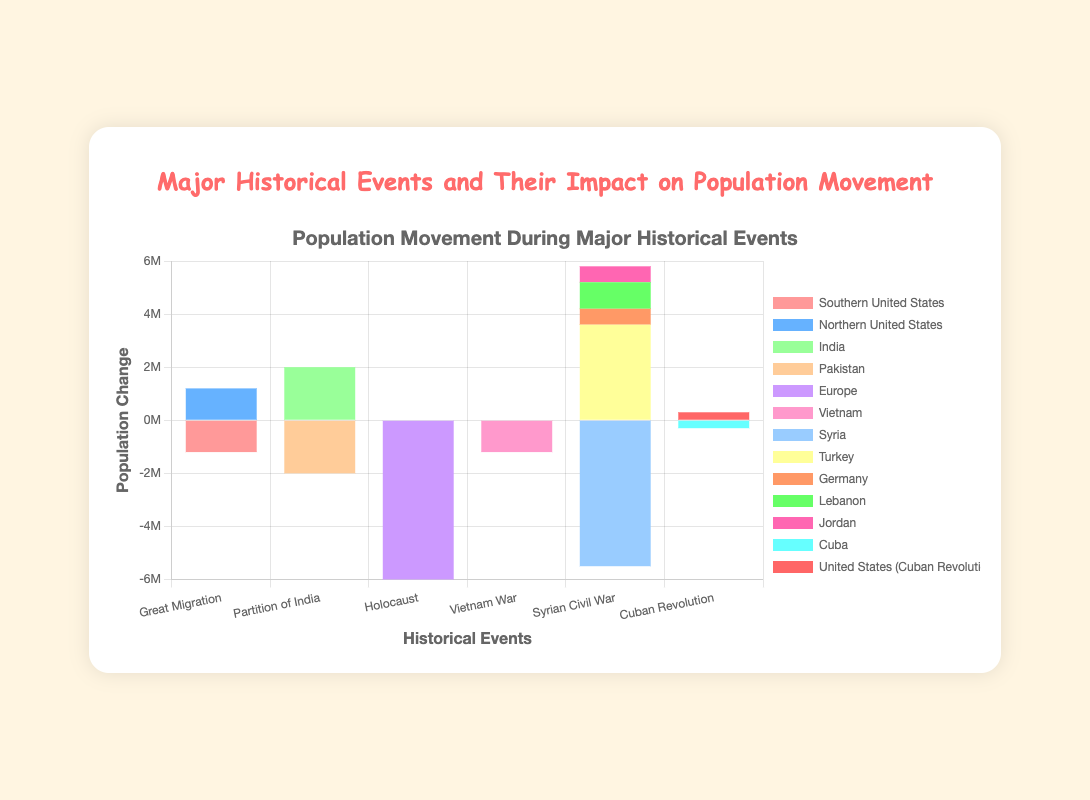What was the population change in India and Pakistan due to the Partition of India? For the Partition of India in 1947, India experienced a Hindu and Sikh inward movement of 8,000,000 and a Muslim outward movement of -6,000,000. Pakistan experienced a Muslim inward movement of 6,000,000 and a Hindu and Sikh outward movement of -8,000,000, resulting in total changes of 2,000,000 for India and -2,000,000 for Pakistan.
Answer: 2,000,000 (India), -2,000,000 (Pakistan) Which geographic area had the greatest outward movement during the events depicted in the chart? The bar labeled "Europe" under "Holocaust" shows the greatest outward movement with a negative population change of -6,000,000.
Answer: Europe Compare the population changes for Syria and Vietnam during their respective conflicts. During the Syrian Civil War in 2011, Syria experienced a population change of -5,500,000 (outward movement). During the Vietnam War in 1975, Vietnam experienced a population change of -1,200,000 (outward movement). Syria had a greater outward movement compared to Vietnam.
Answer: Syria had a greater outward movement In which event did Turkey see an increase in population, and by how much? During the Syrian Civil War in 2011, Turkey experienced an inward movement of 3,600,000 refugees, which increased its population by that amount.
Answer: 3,600,000 What is the combined effect on the population of the Northern United States and the Southern United States during the Great Migration? During the Great Migration, the Northern United States had an inward movement of 1,200,000, and the Southern United States had an outward movement of -1,200,000. The combined effect is balanced, resulting in a net population change of 0 when considering both areas together.
Answer: 0 Visually, which event has the most evenly distributed population changes among affected geographic areas? The "Partition of India" event shows population changes in two geographic areas (India and Pakistan) that are relatively balanced and symmetrical, with each area having one inward and one outward movement that are equal in magnitude but opposite in direction.
Answer: Partition of India 